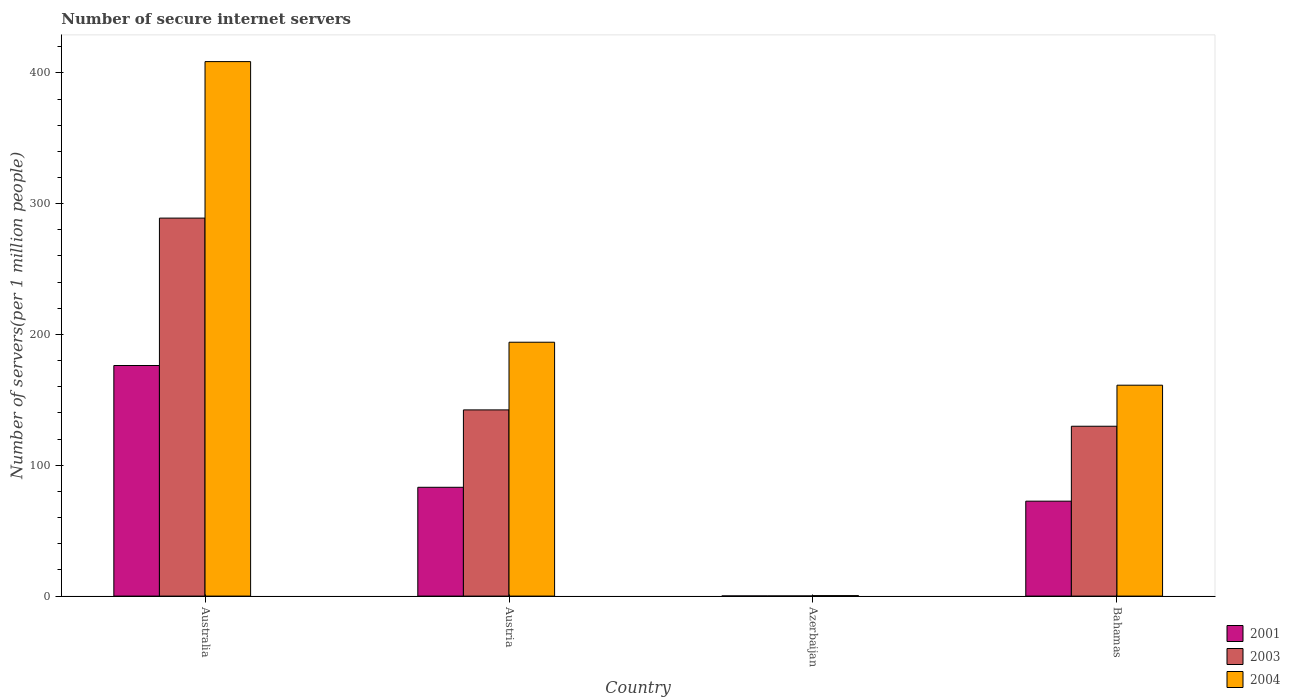How many different coloured bars are there?
Your answer should be very brief. 3. How many groups of bars are there?
Your response must be concise. 4. Are the number of bars per tick equal to the number of legend labels?
Offer a very short reply. Yes. Are the number of bars on each tick of the X-axis equal?
Give a very brief answer. Yes. How many bars are there on the 4th tick from the left?
Your answer should be very brief. 3. In how many cases, is the number of bars for a given country not equal to the number of legend labels?
Your response must be concise. 0. What is the number of secure internet servers in 2001 in Australia?
Give a very brief answer. 176.27. Across all countries, what is the maximum number of secure internet servers in 2001?
Make the answer very short. 176.27. Across all countries, what is the minimum number of secure internet servers in 2001?
Offer a very short reply. 0.12. In which country was the number of secure internet servers in 2004 minimum?
Your answer should be compact. Azerbaijan. What is the total number of secure internet servers in 2001 in the graph?
Give a very brief answer. 332.16. What is the difference between the number of secure internet servers in 2003 in Australia and that in Austria?
Your response must be concise. 146.62. What is the difference between the number of secure internet servers in 2003 in Austria and the number of secure internet servers in 2001 in Azerbaijan?
Provide a succinct answer. 142.22. What is the average number of secure internet servers in 2001 per country?
Offer a terse response. 83.04. What is the difference between the number of secure internet servers of/in 2004 and number of secure internet servers of/in 2001 in Bahamas?
Keep it short and to the point. 88.65. What is the ratio of the number of secure internet servers in 2001 in Austria to that in Azerbaijan?
Offer a terse response. 674.73. Is the number of secure internet servers in 2001 in Australia less than that in Austria?
Offer a very short reply. No. What is the difference between the highest and the second highest number of secure internet servers in 2001?
Keep it short and to the point. 103.7. What is the difference between the highest and the lowest number of secure internet servers in 2004?
Make the answer very short. 408.24. Is the sum of the number of secure internet servers in 2003 in Austria and Bahamas greater than the maximum number of secure internet servers in 2004 across all countries?
Provide a succinct answer. No. What does the 1st bar from the left in Azerbaijan represents?
Your answer should be compact. 2001. What does the 1st bar from the right in Australia represents?
Give a very brief answer. 2004. How many bars are there?
Give a very brief answer. 12. Are all the bars in the graph horizontal?
Your answer should be compact. No. What is the title of the graph?
Ensure brevity in your answer.  Number of secure internet servers. What is the label or title of the Y-axis?
Your answer should be very brief. Number of servers(per 1 million people). What is the Number of servers(per 1 million people) in 2001 in Australia?
Offer a very short reply. 176.27. What is the Number of servers(per 1 million people) in 2003 in Australia?
Provide a short and direct response. 288.96. What is the Number of servers(per 1 million people) in 2004 in Australia?
Ensure brevity in your answer.  408.6. What is the Number of servers(per 1 million people) in 2001 in Austria?
Provide a short and direct response. 83.19. What is the Number of servers(per 1 million people) of 2003 in Austria?
Offer a terse response. 142.34. What is the Number of servers(per 1 million people) in 2004 in Austria?
Your response must be concise. 194.08. What is the Number of servers(per 1 million people) in 2001 in Azerbaijan?
Offer a terse response. 0.12. What is the Number of servers(per 1 million people) of 2003 in Azerbaijan?
Offer a terse response. 0.12. What is the Number of servers(per 1 million people) in 2004 in Azerbaijan?
Provide a short and direct response. 0.36. What is the Number of servers(per 1 million people) of 2001 in Bahamas?
Make the answer very short. 72.57. What is the Number of servers(per 1 million people) in 2003 in Bahamas?
Your answer should be compact. 129.85. What is the Number of servers(per 1 million people) in 2004 in Bahamas?
Offer a terse response. 161.22. Across all countries, what is the maximum Number of servers(per 1 million people) in 2001?
Offer a terse response. 176.27. Across all countries, what is the maximum Number of servers(per 1 million people) in 2003?
Offer a terse response. 288.96. Across all countries, what is the maximum Number of servers(per 1 million people) of 2004?
Your answer should be compact. 408.6. Across all countries, what is the minimum Number of servers(per 1 million people) in 2001?
Keep it short and to the point. 0.12. Across all countries, what is the minimum Number of servers(per 1 million people) of 2003?
Your answer should be very brief. 0.12. Across all countries, what is the minimum Number of servers(per 1 million people) of 2004?
Provide a succinct answer. 0.36. What is the total Number of servers(per 1 million people) in 2001 in the graph?
Give a very brief answer. 332.16. What is the total Number of servers(per 1 million people) in 2003 in the graph?
Ensure brevity in your answer.  561.27. What is the total Number of servers(per 1 million people) in 2004 in the graph?
Keep it short and to the point. 764.26. What is the difference between the Number of servers(per 1 million people) of 2001 in Australia and that in Austria?
Give a very brief answer. 93.09. What is the difference between the Number of servers(per 1 million people) of 2003 in Australia and that in Austria?
Give a very brief answer. 146.62. What is the difference between the Number of servers(per 1 million people) in 2004 in Australia and that in Austria?
Offer a terse response. 214.52. What is the difference between the Number of servers(per 1 million people) in 2001 in Australia and that in Azerbaijan?
Provide a short and direct response. 176.15. What is the difference between the Number of servers(per 1 million people) of 2003 in Australia and that in Azerbaijan?
Give a very brief answer. 288.84. What is the difference between the Number of servers(per 1 million people) in 2004 in Australia and that in Azerbaijan?
Provide a short and direct response. 408.24. What is the difference between the Number of servers(per 1 million people) in 2001 in Australia and that in Bahamas?
Offer a very short reply. 103.7. What is the difference between the Number of servers(per 1 million people) in 2003 in Australia and that in Bahamas?
Your response must be concise. 159.11. What is the difference between the Number of servers(per 1 million people) in 2004 in Australia and that in Bahamas?
Ensure brevity in your answer.  247.38. What is the difference between the Number of servers(per 1 million people) of 2001 in Austria and that in Azerbaijan?
Your answer should be compact. 83.06. What is the difference between the Number of servers(per 1 million people) in 2003 in Austria and that in Azerbaijan?
Give a very brief answer. 142.22. What is the difference between the Number of servers(per 1 million people) in 2004 in Austria and that in Azerbaijan?
Your answer should be compact. 193.72. What is the difference between the Number of servers(per 1 million people) in 2001 in Austria and that in Bahamas?
Your response must be concise. 10.61. What is the difference between the Number of servers(per 1 million people) of 2003 in Austria and that in Bahamas?
Offer a very short reply. 12.49. What is the difference between the Number of servers(per 1 million people) in 2004 in Austria and that in Bahamas?
Offer a very short reply. 32.86. What is the difference between the Number of servers(per 1 million people) of 2001 in Azerbaijan and that in Bahamas?
Your answer should be compact. -72.45. What is the difference between the Number of servers(per 1 million people) in 2003 in Azerbaijan and that in Bahamas?
Offer a terse response. -129.73. What is the difference between the Number of servers(per 1 million people) of 2004 in Azerbaijan and that in Bahamas?
Your answer should be compact. -160.86. What is the difference between the Number of servers(per 1 million people) in 2001 in Australia and the Number of servers(per 1 million people) in 2003 in Austria?
Offer a very short reply. 33.93. What is the difference between the Number of servers(per 1 million people) of 2001 in Australia and the Number of servers(per 1 million people) of 2004 in Austria?
Keep it short and to the point. -17.8. What is the difference between the Number of servers(per 1 million people) of 2003 in Australia and the Number of servers(per 1 million people) of 2004 in Austria?
Provide a short and direct response. 94.88. What is the difference between the Number of servers(per 1 million people) in 2001 in Australia and the Number of servers(per 1 million people) in 2003 in Azerbaijan?
Your answer should be compact. 176.15. What is the difference between the Number of servers(per 1 million people) of 2001 in Australia and the Number of servers(per 1 million people) of 2004 in Azerbaijan?
Keep it short and to the point. 175.91. What is the difference between the Number of servers(per 1 million people) of 2003 in Australia and the Number of servers(per 1 million people) of 2004 in Azerbaijan?
Keep it short and to the point. 288.6. What is the difference between the Number of servers(per 1 million people) in 2001 in Australia and the Number of servers(per 1 million people) in 2003 in Bahamas?
Your answer should be compact. 46.43. What is the difference between the Number of servers(per 1 million people) of 2001 in Australia and the Number of servers(per 1 million people) of 2004 in Bahamas?
Offer a terse response. 15.05. What is the difference between the Number of servers(per 1 million people) of 2003 in Australia and the Number of servers(per 1 million people) of 2004 in Bahamas?
Give a very brief answer. 127.74. What is the difference between the Number of servers(per 1 million people) in 2001 in Austria and the Number of servers(per 1 million people) in 2003 in Azerbaijan?
Give a very brief answer. 83.06. What is the difference between the Number of servers(per 1 million people) of 2001 in Austria and the Number of servers(per 1 million people) of 2004 in Azerbaijan?
Provide a short and direct response. 82.82. What is the difference between the Number of servers(per 1 million people) in 2003 in Austria and the Number of servers(per 1 million people) in 2004 in Azerbaijan?
Make the answer very short. 141.98. What is the difference between the Number of servers(per 1 million people) in 2001 in Austria and the Number of servers(per 1 million people) in 2003 in Bahamas?
Your response must be concise. -46.66. What is the difference between the Number of servers(per 1 million people) in 2001 in Austria and the Number of servers(per 1 million people) in 2004 in Bahamas?
Your response must be concise. -78.04. What is the difference between the Number of servers(per 1 million people) of 2003 in Austria and the Number of servers(per 1 million people) of 2004 in Bahamas?
Offer a very short reply. -18.88. What is the difference between the Number of servers(per 1 million people) of 2001 in Azerbaijan and the Number of servers(per 1 million people) of 2003 in Bahamas?
Your answer should be compact. -129.72. What is the difference between the Number of servers(per 1 million people) of 2001 in Azerbaijan and the Number of servers(per 1 million people) of 2004 in Bahamas?
Make the answer very short. -161.1. What is the difference between the Number of servers(per 1 million people) in 2003 in Azerbaijan and the Number of servers(per 1 million people) in 2004 in Bahamas?
Give a very brief answer. -161.1. What is the average Number of servers(per 1 million people) in 2001 per country?
Provide a succinct answer. 83.04. What is the average Number of servers(per 1 million people) in 2003 per country?
Make the answer very short. 140.32. What is the average Number of servers(per 1 million people) in 2004 per country?
Offer a very short reply. 191.06. What is the difference between the Number of servers(per 1 million people) in 2001 and Number of servers(per 1 million people) in 2003 in Australia?
Give a very brief answer. -112.69. What is the difference between the Number of servers(per 1 million people) of 2001 and Number of servers(per 1 million people) of 2004 in Australia?
Provide a succinct answer. -232.32. What is the difference between the Number of servers(per 1 million people) in 2003 and Number of servers(per 1 million people) in 2004 in Australia?
Provide a succinct answer. -119.64. What is the difference between the Number of servers(per 1 million people) of 2001 and Number of servers(per 1 million people) of 2003 in Austria?
Your response must be concise. -59.15. What is the difference between the Number of servers(per 1 million people) in 2001 and Number of servers(per 1 million people) in 2004 in Austria?
Your answer should be compact. -110.89. What is the difference between the Number of servers(per 1 million people) of 2003 and Number of servers(per 1 million people) of 2004 in Austria?
Provide a succinct answer. -51.74. What is the difference between the Number of servers(per 1 million people) in 2001 and Number of servers(per 1 million people) in 2003 in Azerbaijan?
Give a very brief answer. 0. What is the difference between the Number of servers(per 1 million people) in 2001 and Number of servers(per 1 million people) in 2004 in Azerbaijan?
Make the answer very short. -0.24. What is the difference between the Number of servers(per 1 million people) in 2003 and Number of servers(per 1 million people) in 2004 in Azerbaijan?
Ensure brevity in your answer.  -0.24. What is the difference between the Number of servers(per 1 million people) in 2001 and Number of servers(per 1 million people) in 2003 in Bahamas?
Your answer should be very brief. -57.27. What is the difference between the Number of servers(per 1 million people) of 2001 and Number of servers(per 1 million people) of 2004 in Bahamas?
Your response must be concise. -88.65. What is the difference between the Number of servers(per 1 million people) in 2003 and Number of servers(per 1 million people) in 2004 in Bahamas?
Your response must be concise. -31.37. What is the ratio of the Number of servers(per 1 million people) of 2001 in Australia to that in Austria?
Your answer should be compact. 2.12. What is the ratio of the Number of servers(per 1 million people) of 2003 in Australia to that in Austria?
Keep it short and to the point. 2.03. What is the ratio of the Number of servers(per 1 million people) of 2004 in Australia to that in Austria?
Ensure brevity in your answer.  2.11. What is the ratio of the Number of servers(per 1 million people) in 2001 in Australia to that in Azerbaijan?
Offer a terse response. 1429.79. What is the ratio of the Number of servers(per 1 million people) in 2003 in Australia to that in Azerbaijan?
Make the answer very short. 2379.34. What is the ratio of the Number of servers(per 1 million people) of 2004 in Australia to that in Azerbaijan?
Offer a very short reply. 1131.34. What is the ratio of the Number of servers(per 1 million people) in 2001 in Australia to that in Bahamas?
Provide a short and direct response. 2.43. What is the ratio of the Number of servers(per 1 million people) of 2003 in Australia to that in Bahamas?
Provide a succinct answer. 2.23. What is the ratio of the Number of servers(per 1 million people) of 2004 in Australia to that in Bahamas?
Make the answer very short. 2.53. What is the ratio of the Number of servers(per 1 million people) of 2001 in Austria to that in Azerbaijan?
Your answer should be very brief. 674.73. What is the ratio of the Number of servers(per 1 million people) of 2003 in Austria to that in Azerbaijan?
Give a very brief answer. 1172.04. What is the ratio of the Number of servers(per 1 million people) of 2004 in Austria to that in Azerbaijan?
Offer a very short reply. 537.37. What is the ratio of the Number of servers(per 1 million people) in 2001 in Austria to that in Bahamas?
Provide a short and direct response. 1.15. What is the ratio of the Number of servers(per 1 million people) of 2003 in Austria to that in Bahamas?
Ensure brevity in your answer.  1.1. What is the ratio of the Number of servers(per 1 million people) of 2004 in Austria to that in Bahamas?
Your response must be concise. 1.2. What is the ratio of the Number of servers(per 1 million people) of 2001 in Azerbaijan to that in Bahamas?
Your response must be concise. 0. What is the ratio of the Number of servers(per 1 million people) of 2003 in Azerbaijan to that in Bahamas?
Keep it short and to the point. 0. What is the ratio of the Number of servers(per 1 million people) in 2004 in Azerbaijan to that in Bahamas?
Your answer should be very brief. 0. What is the difference between the highest and the second highest Number of servers(per 1 million people) of 2001?
Your answer should be very brief. 93.09. What is the difference between the highest and the second highest Number of servers(per 1 million people) in 2003?
Ensure brevity in your answer.  146.62. What is the difference between the highest and the second highest Number of servers(per 1 million people) in 2004?
Your answer should be compact. 214.52. What is the difference between the highest and the lowest Number of servers(per 1 million people) of 2001?
Offer a terse response. 176.15. What is the difference between the highest and the lowest Number of servers(per 1 million people) of 2003?
Offer a very short reply. 288.84. What is the difference between the highest and the lowest Number of servers(per 1 million people) of 2004?
Give a very brief answer. 408.24. 